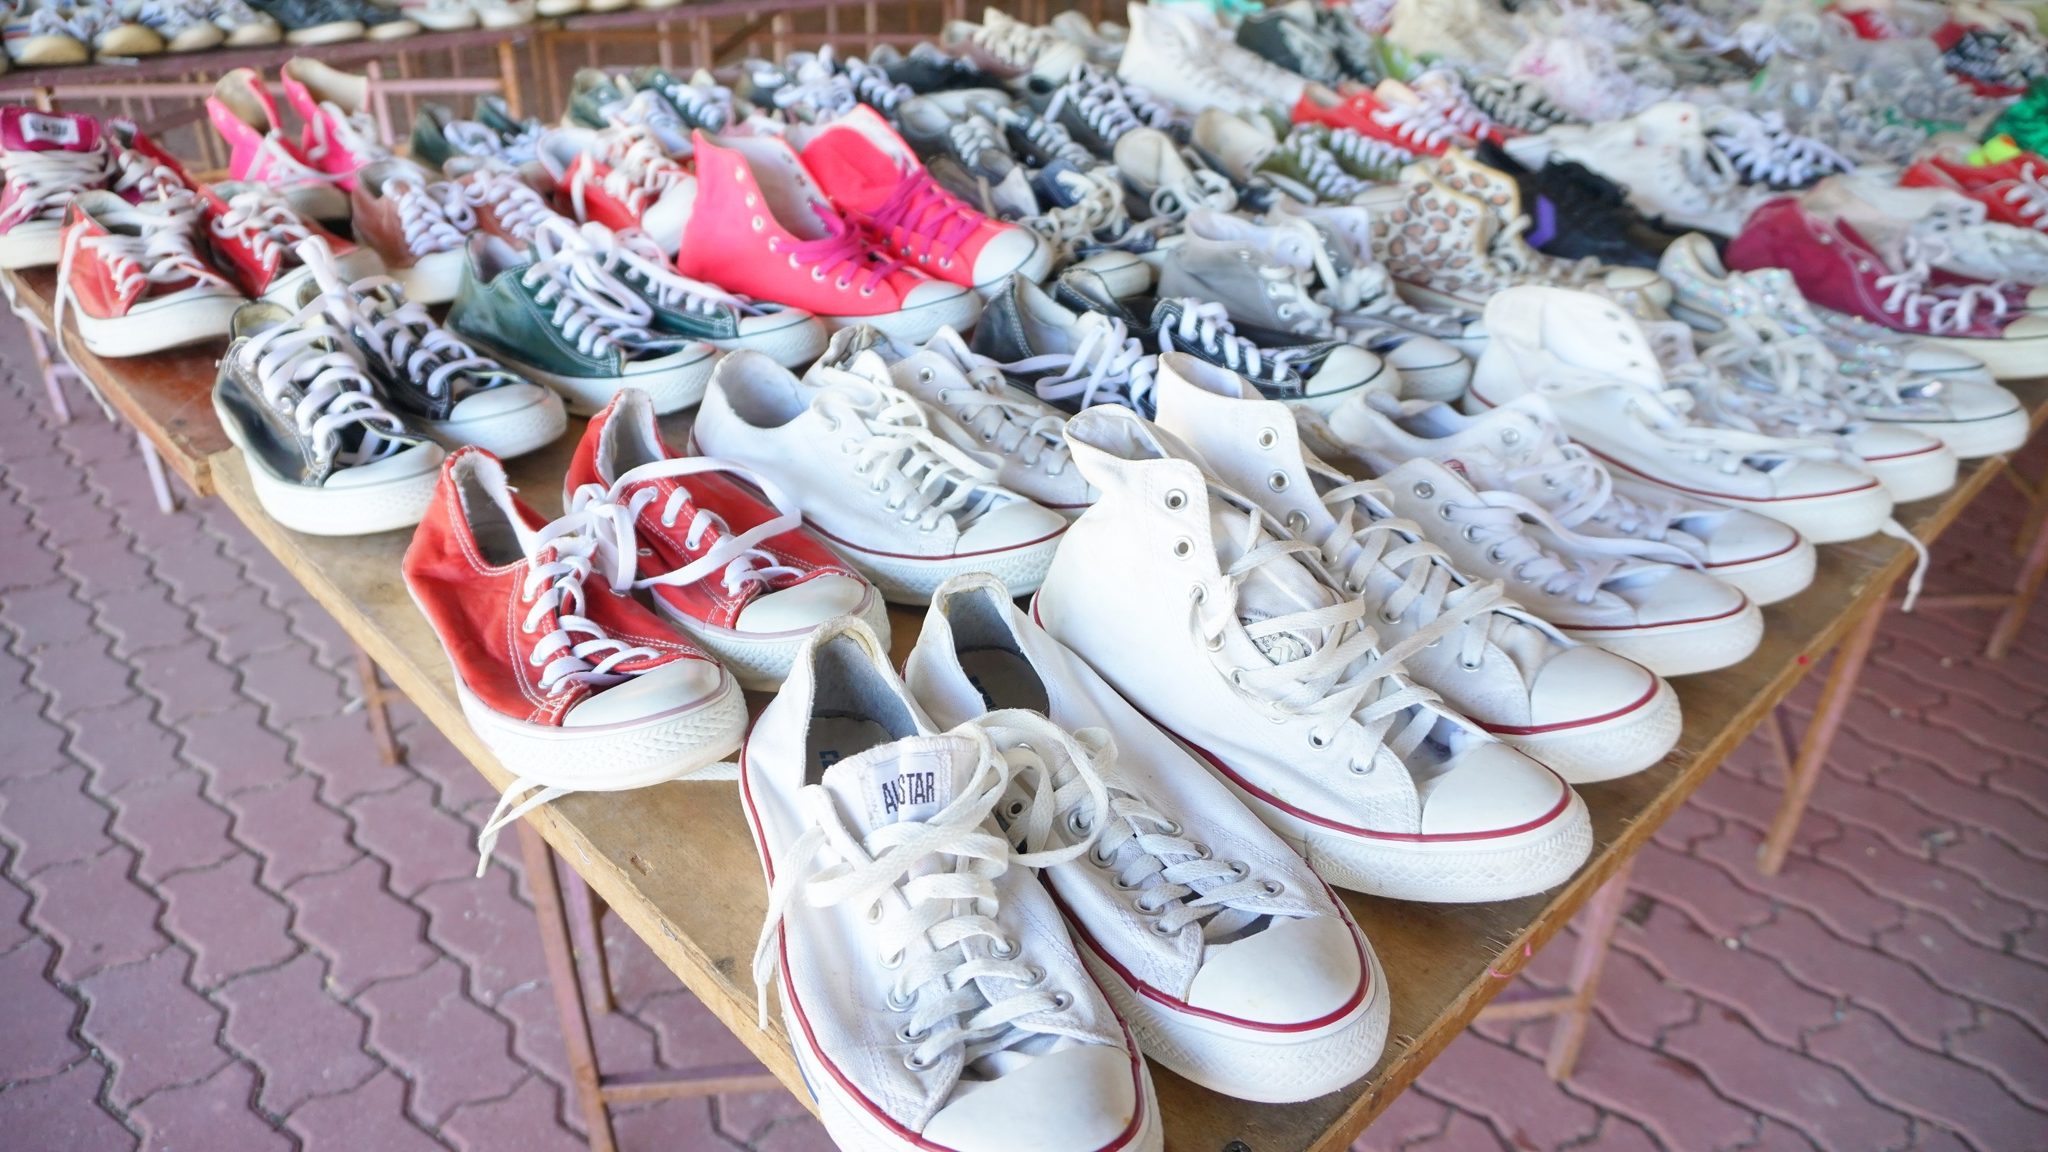Can you describe the types of sneakers on the table? The table is adorned with an assortment of sneakers, notably a variety of Conserve All Stars. These sneakers come in different color schemes including vibrant red, pristine white, grey, pink, and blue. Some pairs are classic low-tops, while others are high-tops. The sneakers appear well-worn and are displayed in a casual, somewhat cluttered arrangement, enhancing the market-like feel of the scene. Why might people be interested in buying these sneakers? People might be interested in buying these sneakers due to their iconic style and brand, affordability in a second-hand setting, or the unique colors and designs that might be hard to find elsewhere. The vintage appeal and the potential for each pair to have a unique history or previous owner might also attract buyers. Do you notice any particular brand taking up most of the space on the table? Yes, the majority of the sneakers on the table appear to be Converse All Stars, identifiable by their classic design and distinctive circular logo, although not all logos are visible. This gives the impression that the sale might be focusing on this popular and well-loved brand. 